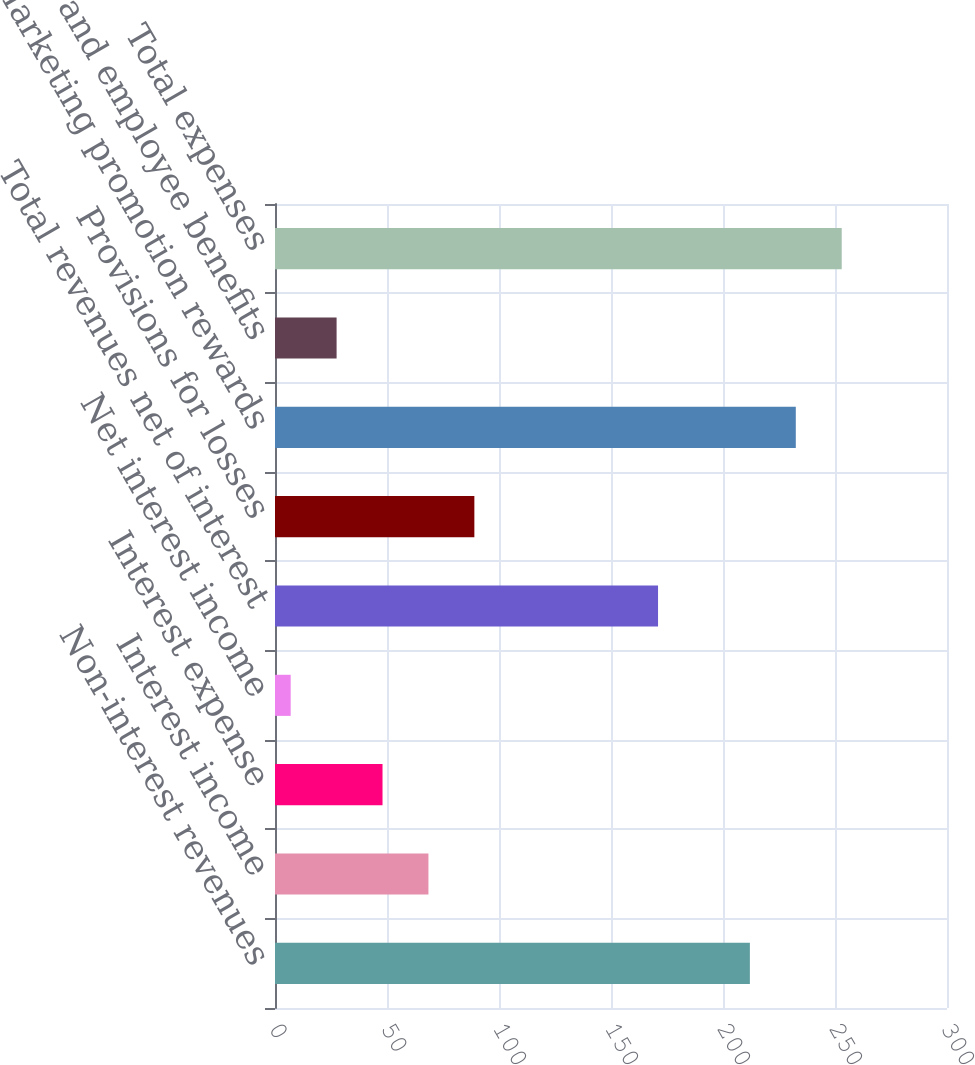Convert chart. <chart><loc_0><loc_0><loc_500><loc_500><bar_chart><fcel>Non-interest revenues<fcel>Interest income<fcel>Interest expense<fcel>Net interest income<fcel>Total revenues net of interest<fcel>Provisions for losses<fcel>Marketing promotion rewards<fcel>Salaries and employee benefits<fcel>Total expenses<nl><fcel>212<fcel>68.5<fcel>48<fcel>7<fcel>171<fcel>89<fcel>232.5<fcel>27.5<fcel>253<nl></chart> 